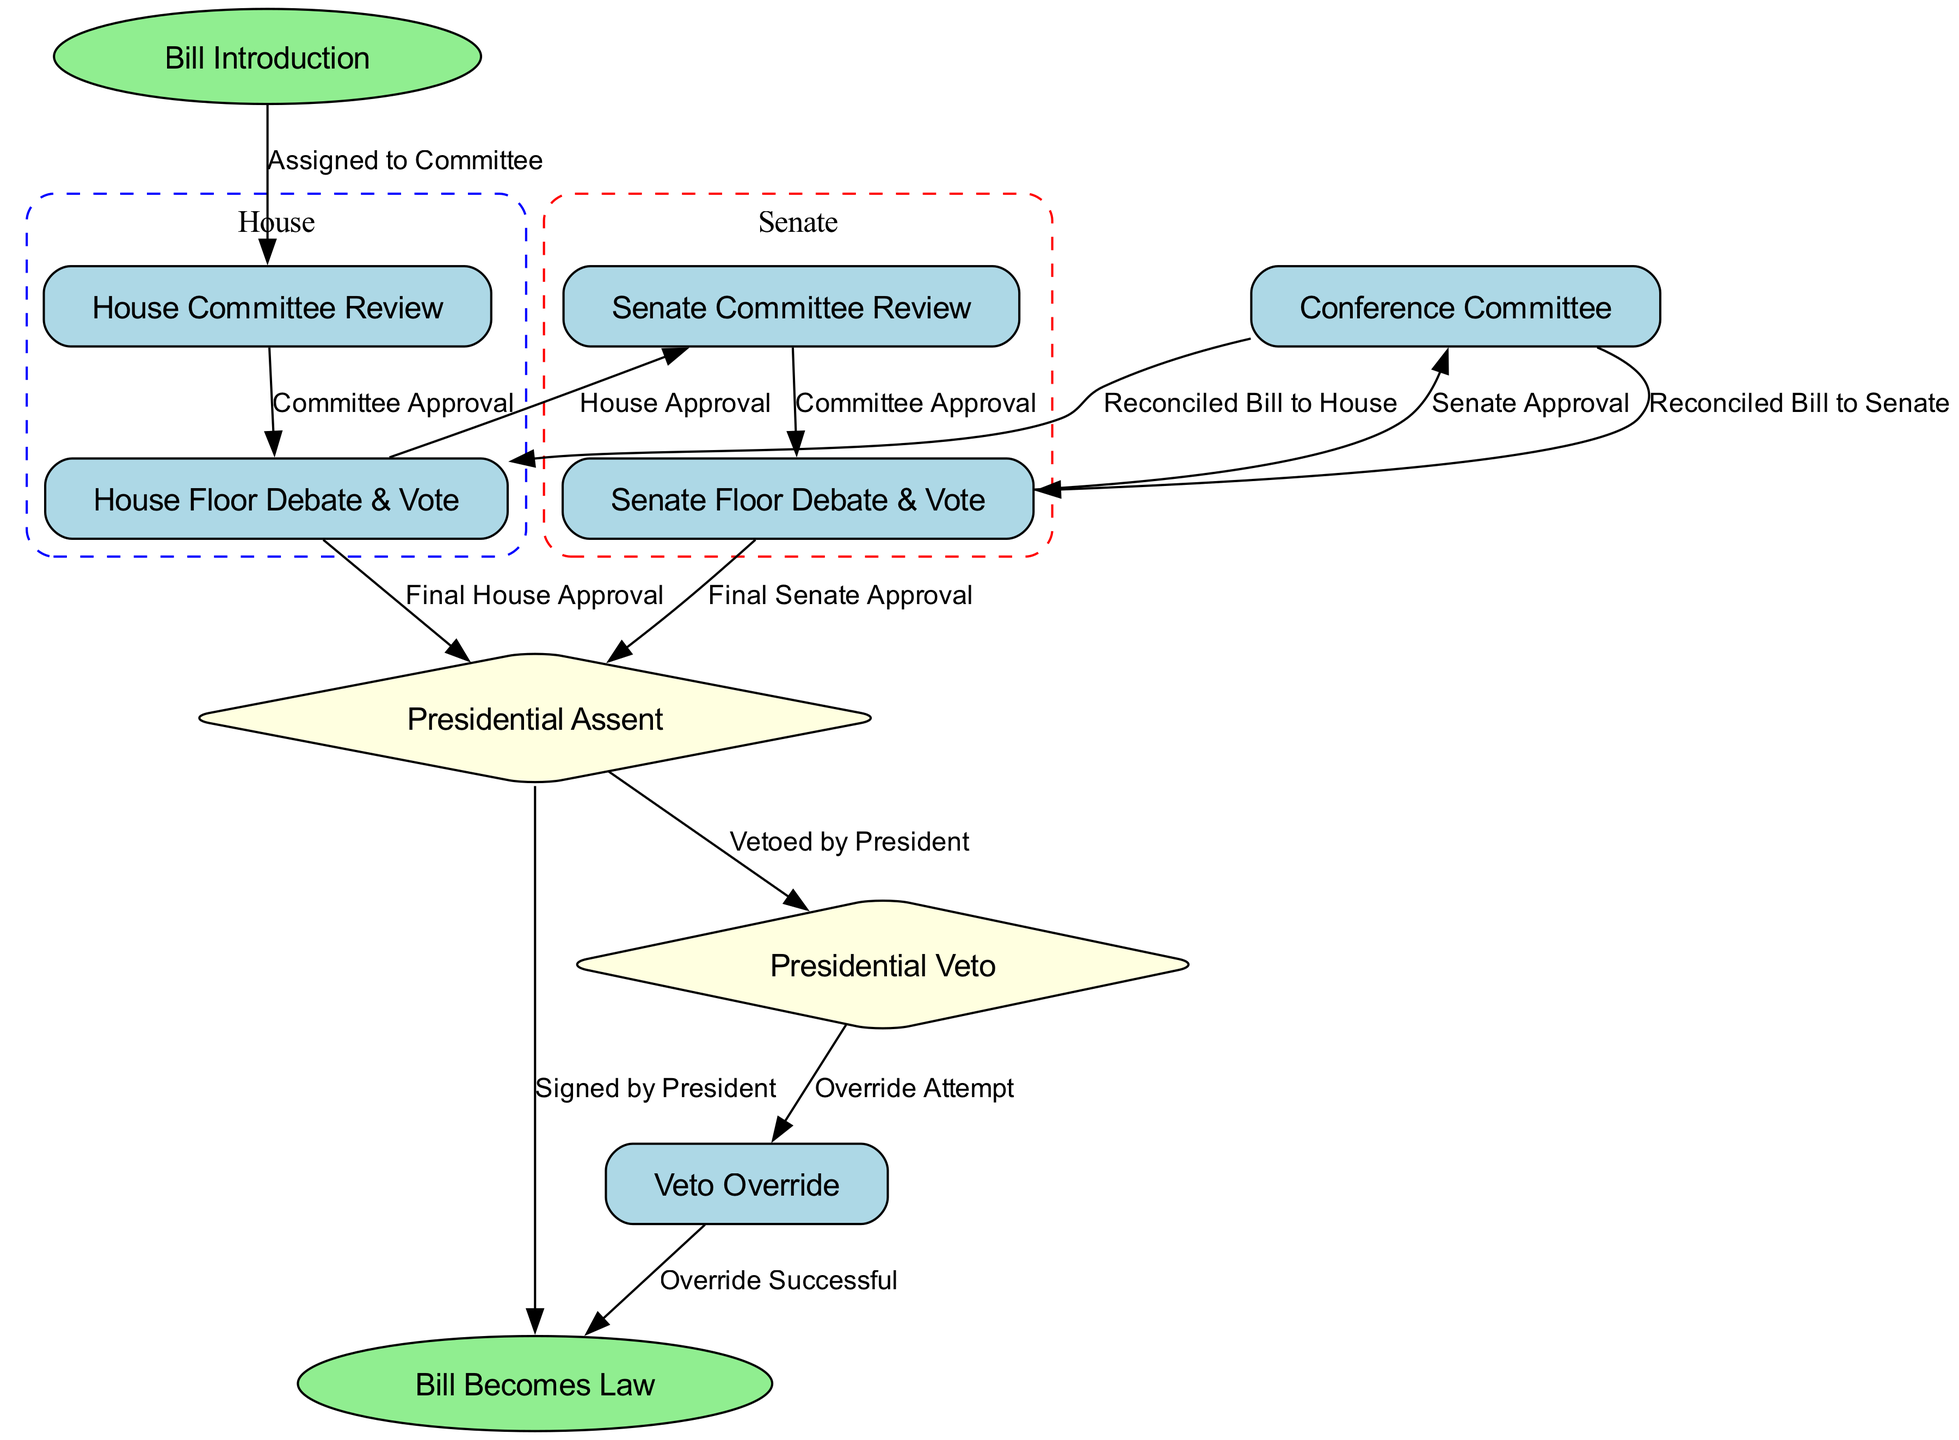What is the first step in the bill process? The diagram shows "Bill Introduction" as the starting node, indicating it is the first action that occurs in the process of passing a bill.
Answer: Bill Introduction How many edges are there leading to the Presidential Assent? The diagram displays two edges leading to "Presidential Assent": one from "Final House Approval" and another from "Final Senate Approval". Hence, there are two pathways.
Answer: 2 What happens after the House Floor Debate & Vote? From the diagram, "House Floor Debate & Vote" leads directly to "Senate Committee Review", indicating that this is the next step in the process after the House approval.
Answer: Senate Committee Review Which node represents a decision point in the process? The "Presidential Assent" node is represented as a diamond shape in the diagram, which indicates that it is a decision point where the President either approves or vetoes the bill.
Answer: Presidential Assent What is the outcome if the Presidential Veto is successful? According to the edges in the diagram, if the President vetoes the bill, it can potentially lead to a "Veto Override". However, if the override is not successful, the bill does not become law, implying failure.
Answer: Bill does not become law What must happen for a bill to become law after a Presidential Veto? The diagram indicates that the "Veto Override" has to occur for the bill to turn into "Law" after a veto has been enacted by the President; this requires approval from Congress.
Answer: Veto Override Which step directly follows Senate Approval? The flowchart indicates that after "Senate Approval", the process goes to "Conference Committee" to reconcile differences between the House and Senate versions of the bill.
Answer: Conference Committee How many main stages are there in the bill process before it becomes law? The diagram clearly delineates the stages in the process; leading from "Bill Introduction" through various committee reviews and votes, there are essentially five main stages before culminating in law.
Answer: 5 What happens after the reconciled bill is sent to the House? In the diagram, after the reconciled bill ("Conference Committee") is sent to the "House Floor", it needs to meet criteria for "Final House Approval" to proceed, making this the necessary next step.
Answer: Final House Approval 